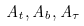<formula> <loc_0><loc_0><loc_500><loc_500>A _ { t } , A _ { b } , A _ { \tau }</formula> 